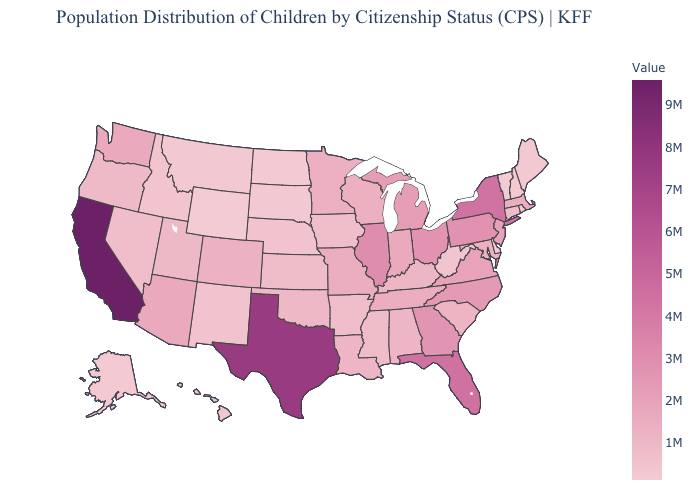Among the states that border Minnesota , which have the lowest value?
Quick response, please. North Dakota. Among the states that border New Hampshire , does Massachusetts have the lowest value?
Quick response, please. No. Among the states that border Iowa , which have the highest value?
Quick response, please. Illinois. Among the states that border Wyoming , does Utah have the highest value?
Give a very brief answer. No. Which states have the lowest value in the South?
Short answer required. Delaware. Does Wyoming have the lowest value in the West?
Short answer required. Yes. Does South Carolina have the highest value in the USA?
Be succinct. No. 